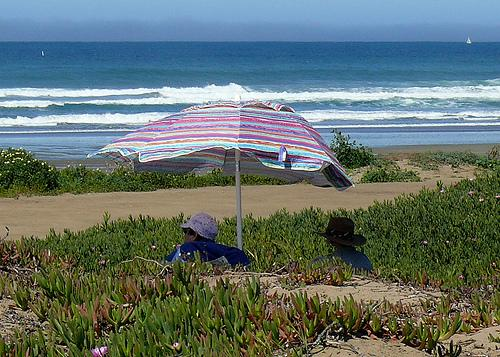Describe an activity being carried out by people in the image near the water. Two individuals are sitting under a sun umbrella at the beach, watching the waves covered in white sea foam. Provide a brief overview of the primary elements in the image. People sitting under a striped sun umbrella at the beach, wearing hats and surrounded by vegetation, with waves crashing toward the shore. Provide details on the environment surrounding the people at the beach. People sitting under an umbrella on a sandy path, surrounded by bushes, green grass, and crashing waves. Mention the types of clothes people are wearing and the crucial elements of the image. People wearing a blue shirt and cowboy hat sit under a striped umbrella, surrounded by green vegetation and crashing waves. State what the people are doing and their location in relation to the ocean. People are sitting under a beach umbrella near the shore, enjoying a view of the calm water and blue skies. Mention the location of the people and the type of umbrella they are under. Two people are enjoying a day at the beach, sitting under a multi-colored striped sun umbrella. What are the significant natural features found around the beach scene? The shore is lined with green vegetation, wet sand, and white sea foam from the crashing waves. Mention the hats and clothes the individuals are wearing while sitting under the umbrella. One person wears a white ball cap, while the other wears a brown cowboy hat, as they sit under a sun umbrella. Explain the environment near the people sitting under the umbrella and discuss the color and style of the umbrella. People are surrounded by green vegetation and ocean waves, sitting under a multicolored striped umbrella. Describe what type of hats the people are wearing while sitting under the umbrella. A person wearing a brown cowboy hat and another person wearing a white ball cap are sitting under an umbrella. 